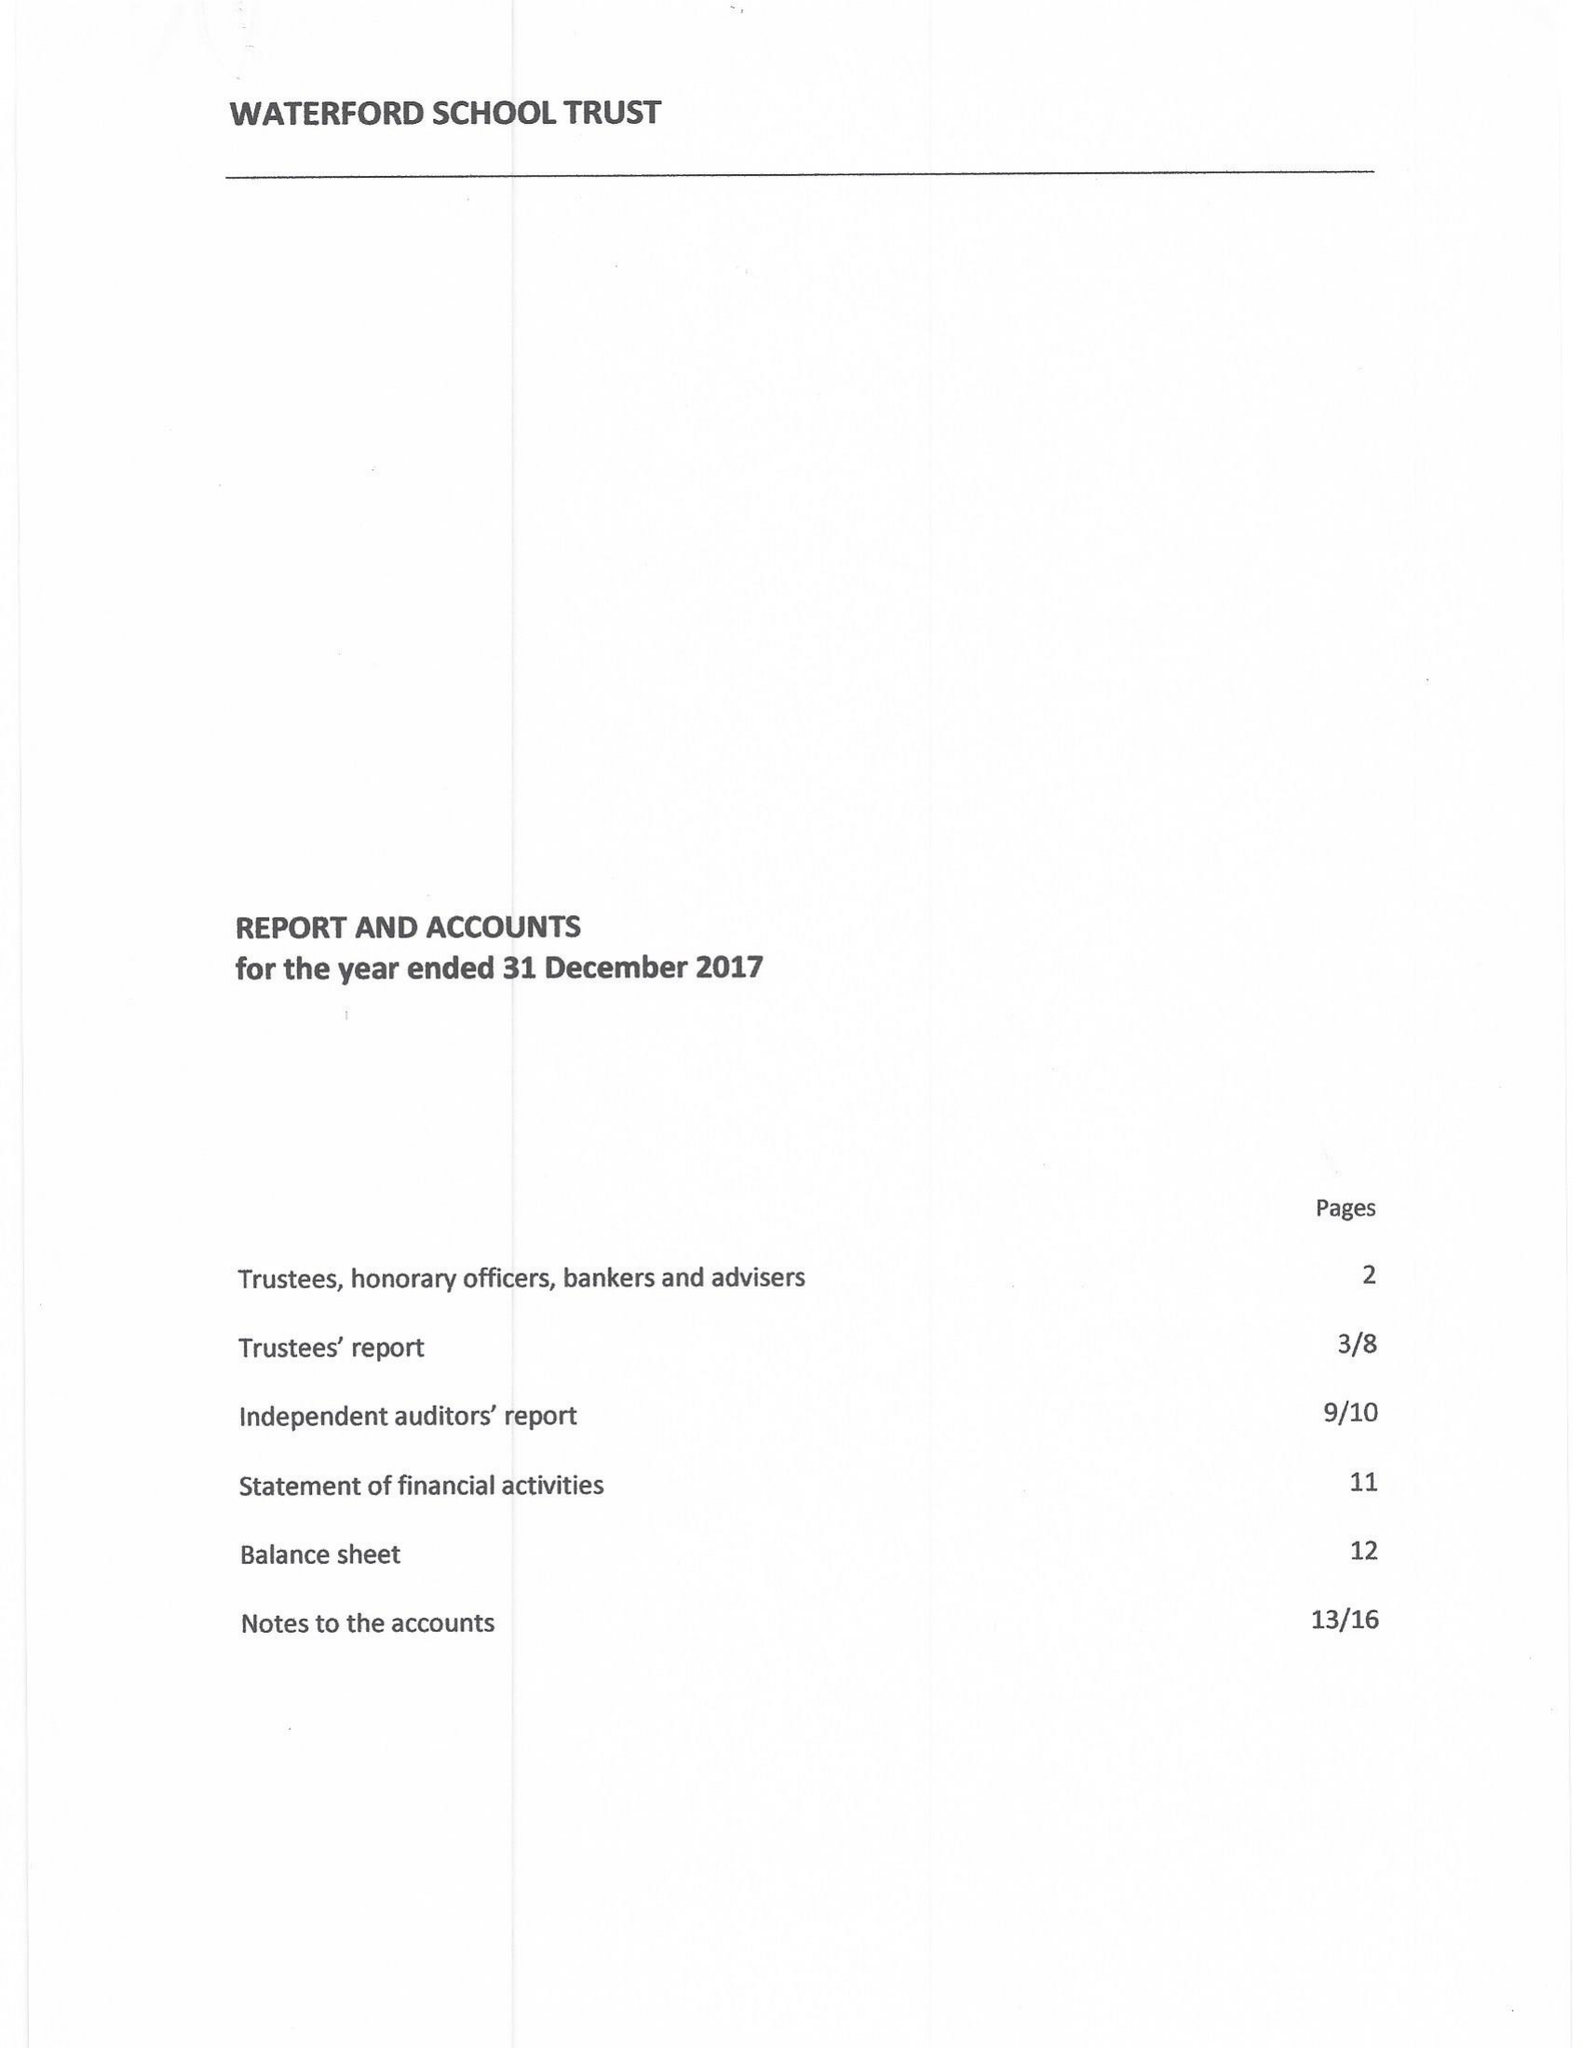What is the value for the report_date?
Answer the question using a single word or phrase. 2017-12-31 